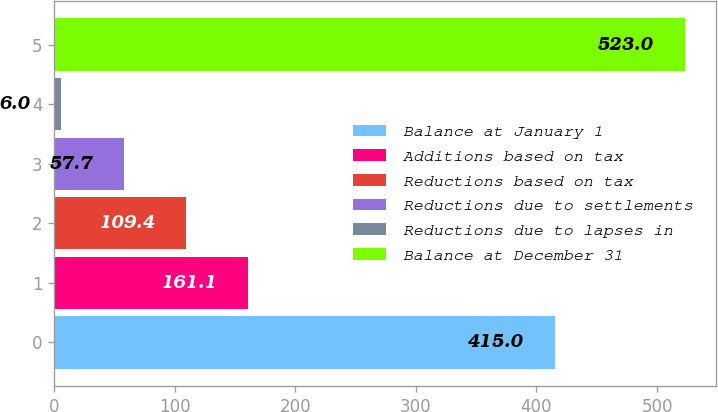Convert chart to OTSL. <chart><loc_0><loc_0><loc_500><loc_500><bar_chart><fcel>Balance at January 1<fcel>Additions based on tax<fcel>Reductions based on tax<fcel>Reductions due to settlements<fcel>Reductions due to lapses in<fcel>Balance at December 31<nl><fcel>415<fcel>161.1<fcel>109.4<fcel>57.7<fcel>6<fcel>523<nl></chart> 